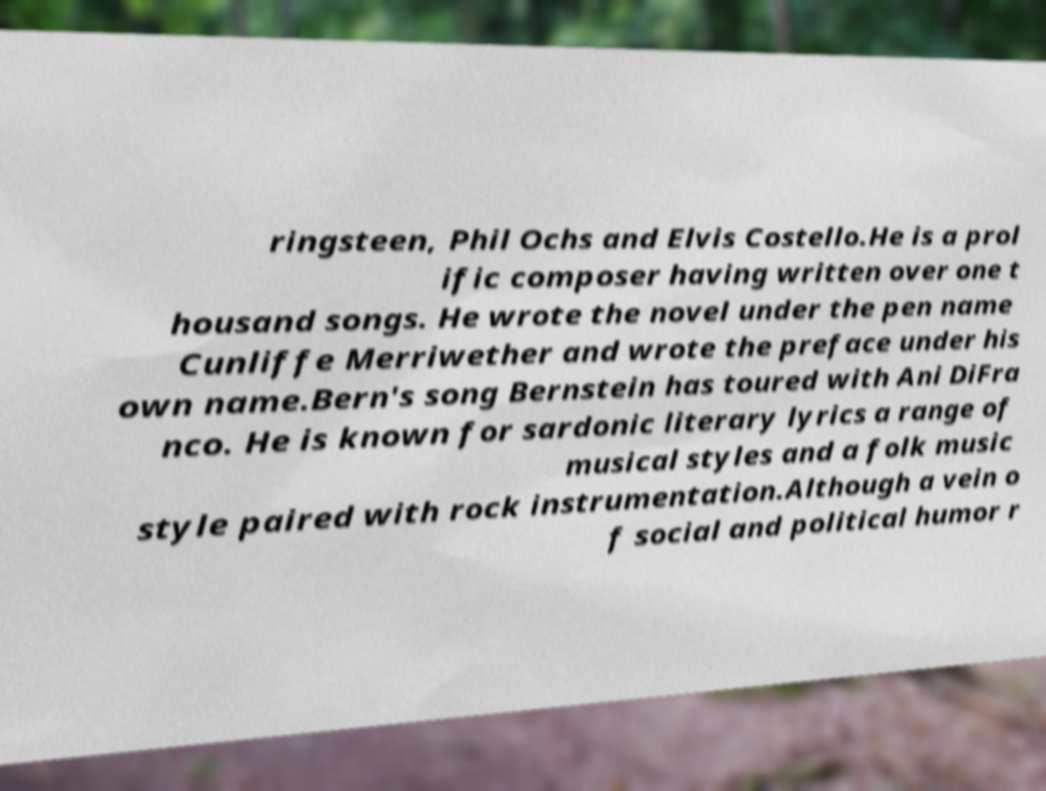Can you accurately transcribe the text from the provided image for me? ringsteen, Phil Ochs and Elvis Costello.He is a prol ific composer having written over one t housand songs. He wrote the novel under the pen name Cunliffe Merriwether and wrote the preface under his own name.Bern's song Bernstein has toured with Ani DiFra nco. He is known for sardonic literary lyrics a range of musical styles and a folk music style paired with rock instrumentation.Although a vein o f social and political humor r 